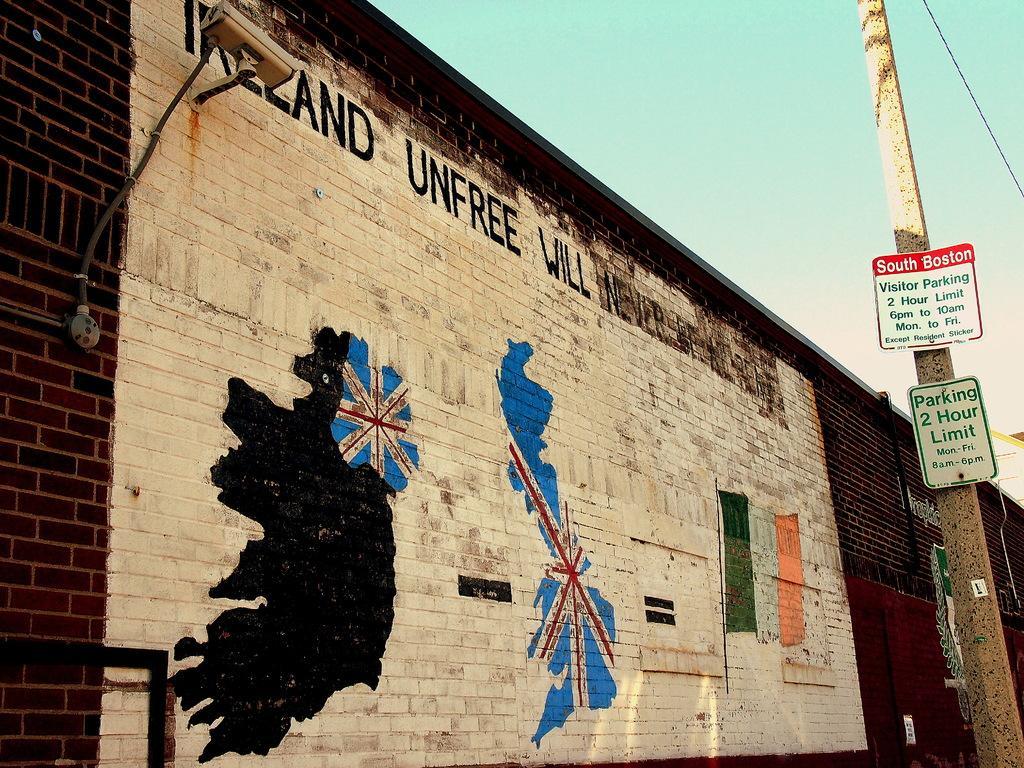Please provide a concise description of this image. In this image there is a wall in the middle. On the wall there is some text at the top. At the bottom it looks like a map painting. On the right side there is a pole to which there are two boards. On the left side there is a video camera which is attached to the wall with the wire. At the top there is the sky. 